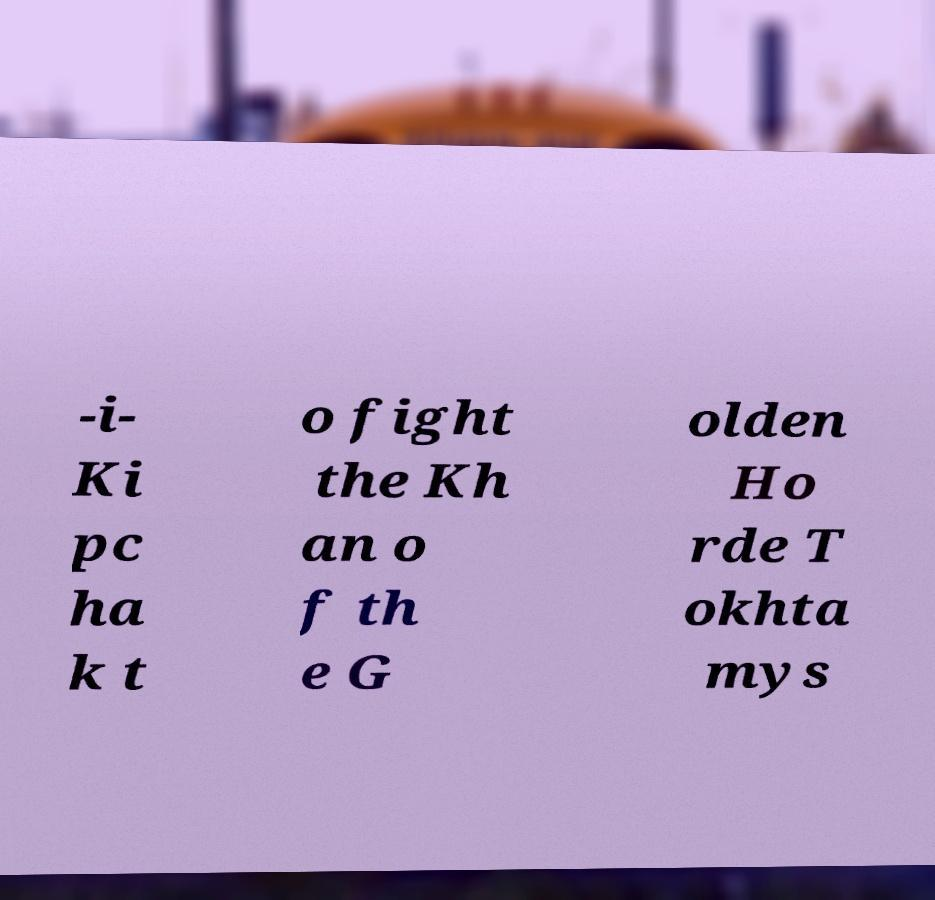Could you extract and type out the text from this image? -i- Ki pc ha k t o fight the Kh an o f th e G olden Ho rde T okhta mys 